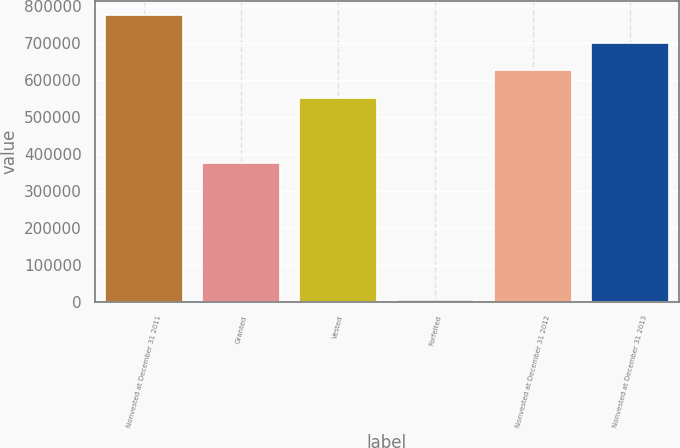Convert chart to OTSL. <chart><loc_0><loc_0><loc_500><loc_500><bar_chart><fcel>Nonvested at December 31 2011<fcel>Granted<fcel>Vested<fcel>Forfeited<fcel>Nonvested at December 31 2012<fcel>Nonvested at December 31 2013<nl><fcel>775646<fcel>374307<fcel>551051<fcel>5162<fcel>625916<fcel>700781<nl></chart> 